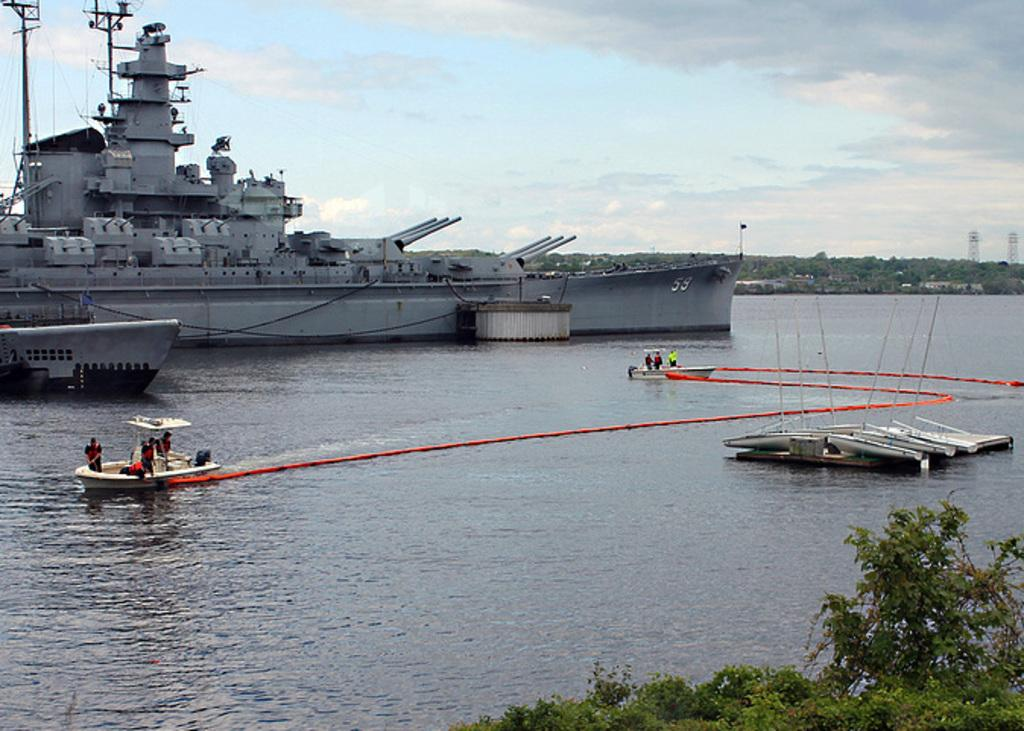What is the main feature of the image? The main feature of the image is a water surface. What is present on the water surface? There are boats and a huge ship on the water surface. What can be seen in the background of the image? There are trees and two towers in the background of the image. Where is the hydrant located in the image? There is no hydrant present in the image. What type of line is connecting the boats in the image? The image does not show any lines connecting the boats. 